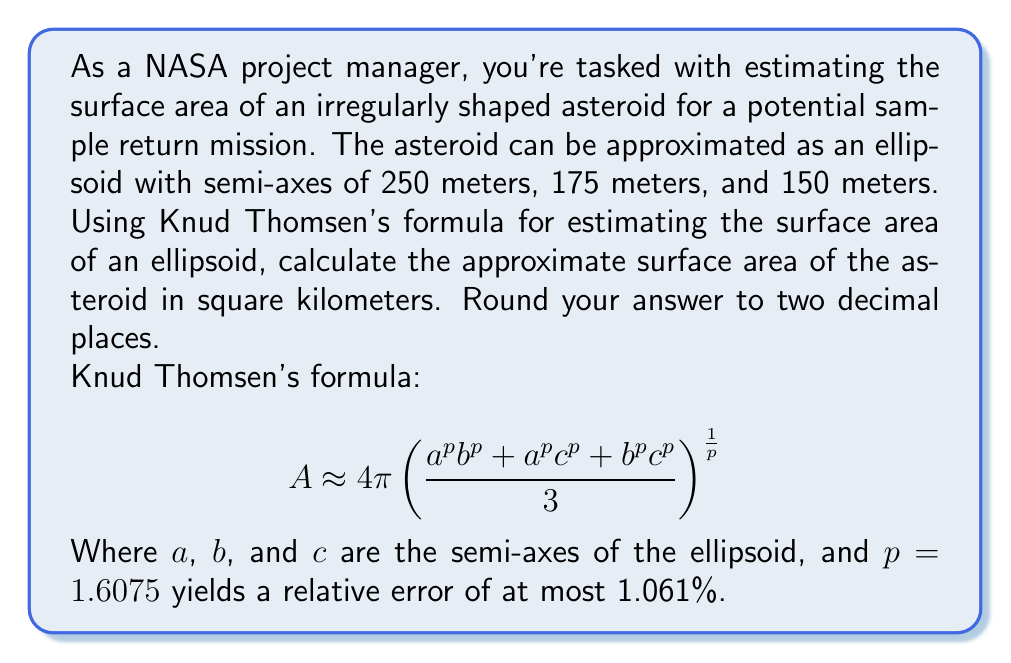Provide a solution to this math problem. To solve this problem, we'll follow these steps:

1. Identify the semi-axes of the ellipsoid:
   $a = 250$ m
   $b = 175$ m
   $c = 150$ m

2. Apply Knud Thomsen's formula with $p = 1.6075$:

   $$A \approx 4\pi \left(\frac{a^p b^p + a^p c^p + b^p c^p}{3}\right)^{\frac{1}{p}}$$

3. Substitute the values:

   $$A \approx 4\pi \left(\frac{250^{1.6075} \cdot 175^{1.6075} + 250^{1.6075} \cdot 150^{1.6075} + 175^{1.6075} \cdot 150^{1.6075}}{3}\right)^{\frac{1}{1.6075}}$$

4. Calculate the result:
   
   $$A \approx 4\pi \left(\frac{1,249,619.86 + 1,131,932.60 + 865,183.95}{3}\right)^{\frac{1}{1.6075}}$$
   
   $$A \approx 4\pi \left(1,082,245.47\right)^{\frac{1}{1.6075}}$$
   
   $$A \approx 4\pi \cdot 294.76$$
   
   $$A \approx 3,704.33 \text{ m}^2$$

5. Convert to square kilometers:
   
   $$A \approx 3,704.33 \cdot 10^{-6} \text{ km}^2 \approx 0.37 \text{ km}^2$$
Answer: The approximate surface area of the asteroid is 0.37 km². 